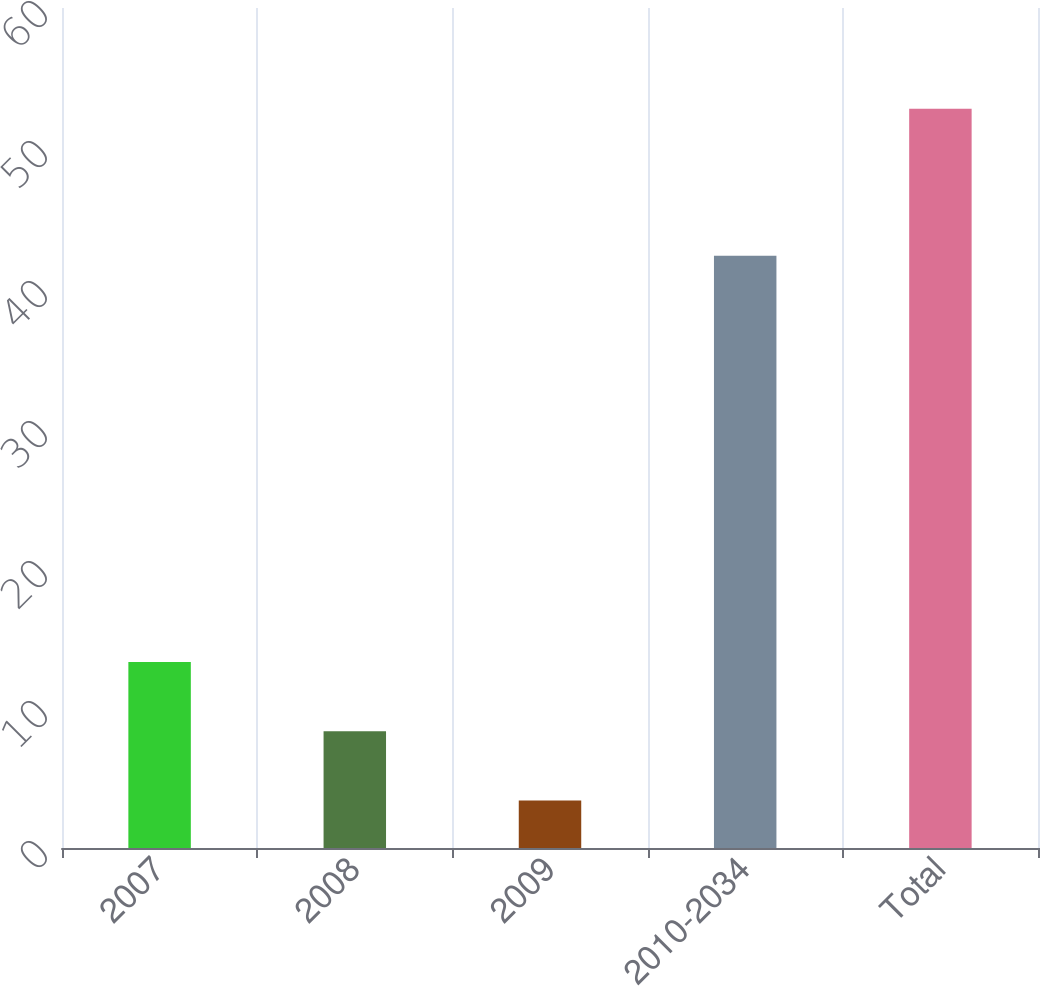<chart> <loc_0><loc_0><loc_500><loc_500><bar_chart><fcel>2007<fcel>2008<fcel>2009<fcel>2010-2034<fcel>Total<nl><fcel>13.28<fcel>8.34<fcel>3.4<fcel>42.3<fcel>52.8<nl></chart> 